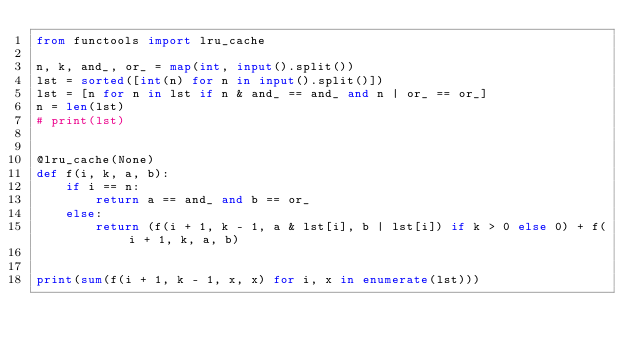<code> <loc_0><loc_0><loc_500><loc_500><_Python_>from functools import lru_cache

n, k, and_, or_ = map(int, input().split())
lst = sorted([int(n) for n in input().split()])
lst = [n for n in lst if n & and_ == and_ and n | or_ == or_]
n = len(lst)
# print(lst)


@lru_cache(None)
def f(i, k, a, b):
    if i == n:
        return a == and_ and b == or_
    else:
        return (f(i + 1, k - 1, a & lst[i], b | lst[i]) if k > 0 else 0) + f(i + 1, k, a, b)


print(sum(f(i + 1, k - 1, x, x) for i, x in enumerate(lst)))</code> 